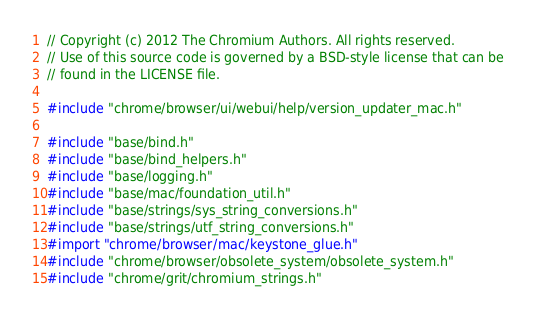<code> <loc_0><loc_0><loc_500><loc_500><_ObjectiveC_>// Copyright (c) 2012 The Chromium Authors. All rights reserved.
// Use of this source code is governed by a BSD-style license that can be
// found in the LICENSE file.

#include "chrome/browser/ui/webui/help/version_updater_mac.h"

#include "base/bind.h"
#include "base/bind_helpers.h"
#include "base/logging.h"
#include "base/mac/foundation_util.h"
#include "base/strings/sys_string_conversions.h"
#include "base/strings/utf_string_conversions.h"
#import "chrome/browser/mac/keystone_glue.h"
#include "chrome/browser/obsolete_system/obsolete_system.h"
#include "chrome/grit/chromium_strings.h"</code> 